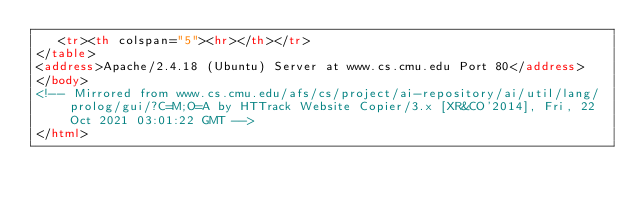<code> <loc_0><loc_0><loc_500><loc_500><_HTML_>   <tr><th colspan="5"><hr></th></tr>
</table>
<address>Apache/2.4.18 (Ubuntu) Server at www.cs.cmu.edu Port 80</address>
</body>
<!-- Mirrored from www.cs.cmu.edu/afs/cs/project/ai-repository/ai/util/lang/prolog/gui/?C=M;O=A by HTTrack Website Copier/3.x [XR&CO'2014], Fri, 22 Oct 2021 03:01:22 GMT -->
</html>
</code> 